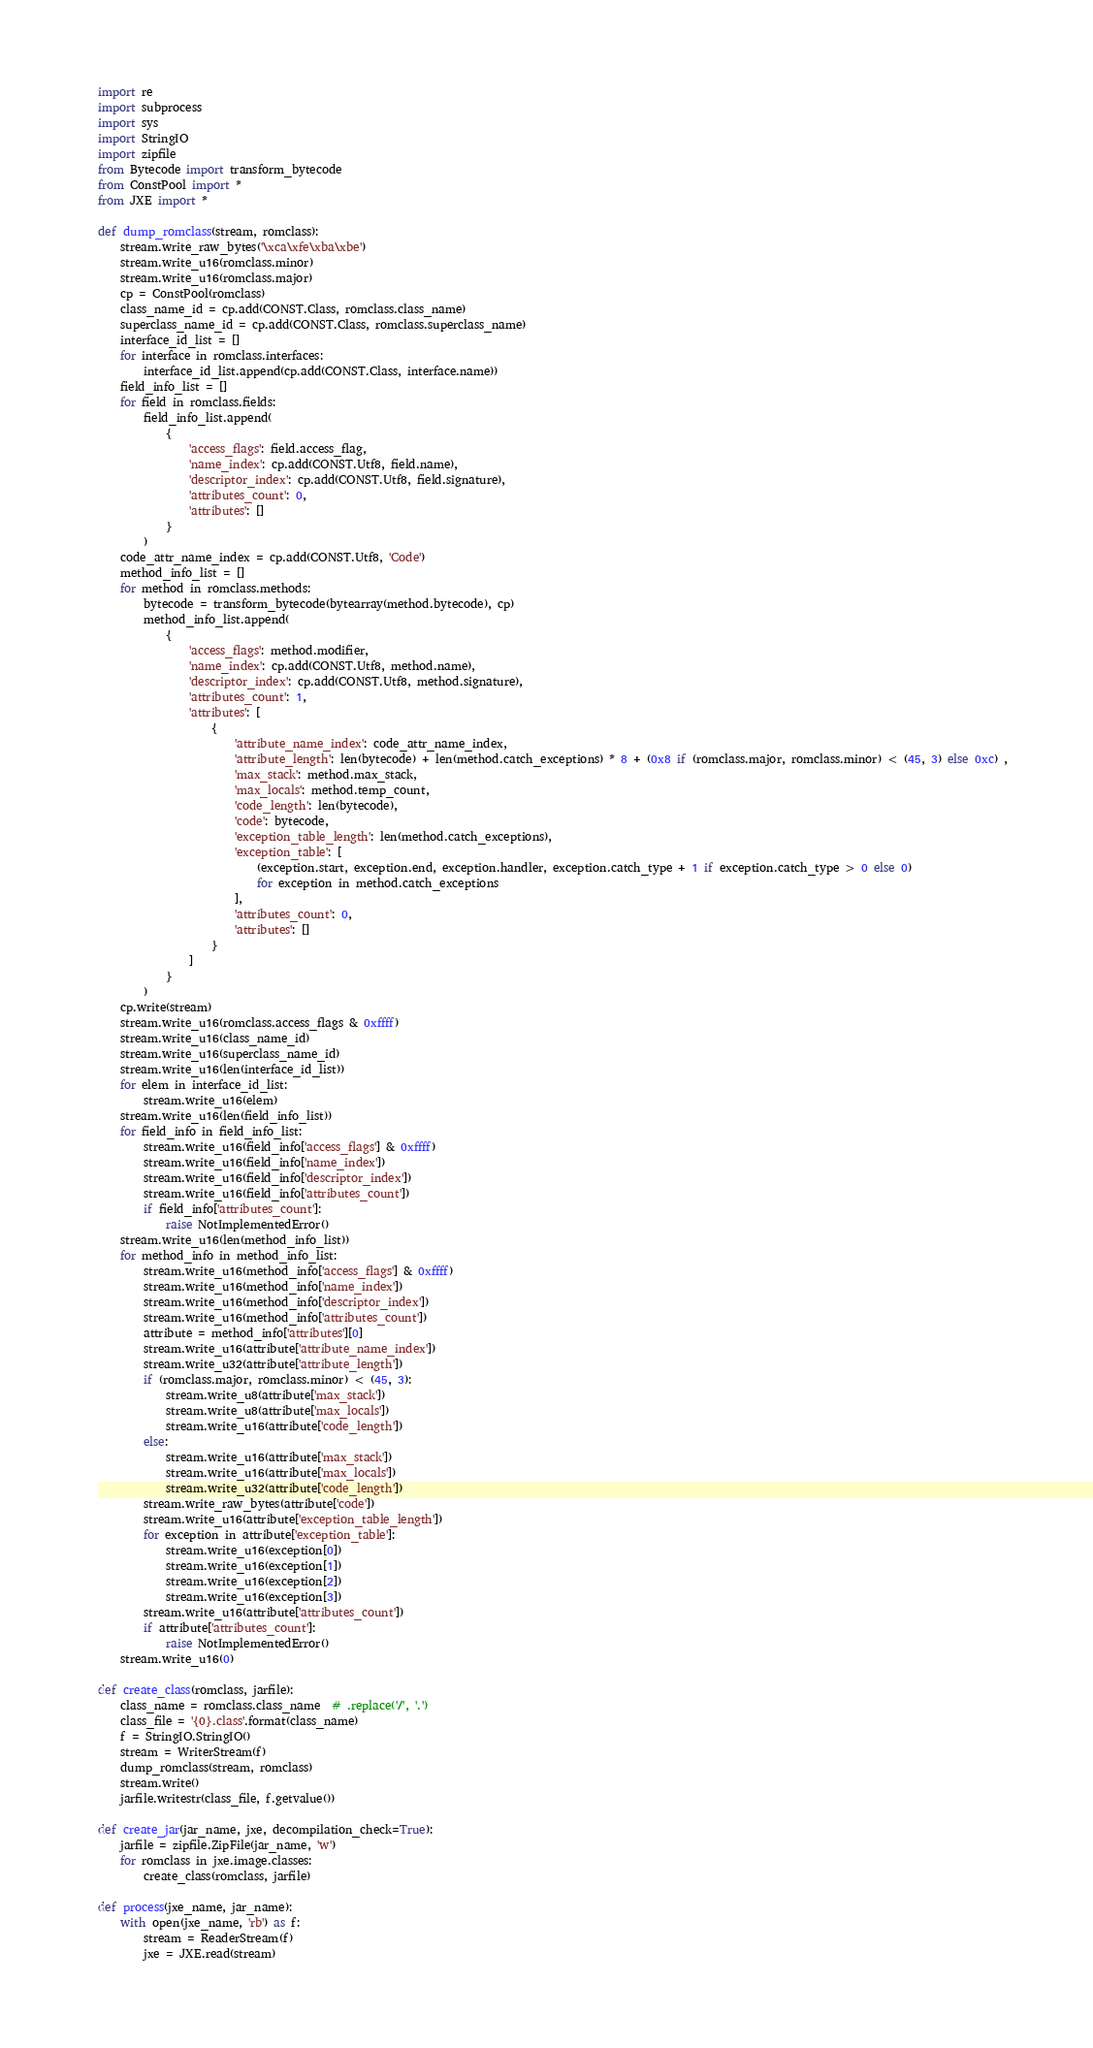<code> <loc_0><loc_0><loc_500><loc_500><_Python_>import re
import subprocess
import sys
import StringIO
import zipfile
from Bytecode import transform_bytecode
from ConstPool import *
from JXE import *

def dump_romclass(stream, romclass):
    stream.write_raw_bytes('\xca\xfe\xba\xbe')
    stream.write_u16(romclass.minor)
    stream.write_u16(romclass.major)
    cp = ConstPool(romclass)
    class_name_id = cp.add(CONST.Class, romclass.class_name)
    superclass_name_id = cp.add(CONST.Class, romclass.superclass_name)
    interface_id_list = []
    for interface in romclass.interfaces:
        interface_id_list.append(cp.add(CONST.Class, interface.name))
    field_info_list = []
    for field in romclass.fields:
        field_info_list.append(
            {
                'access_flags': field.access_flag,
                'name_index': cp.add(CONST.Utf8, field.name),
                'descriptor_index': cp.add(CONST.Utf8, field.signature),
                'attributes_count': 0,
                'attributes': []
            }
        )
    code_attr_name_index = cp.add(CONST.Utf8, 'Code')
    method_info_list = []
    for method in romclass.methods:
        bytecode = transform_bytecode(bytearray(method.bytecode), cp)
        method_info_list.append(
            {
                'access_flags': method.modifier,
                'name_index': cp.add(CONST.Utf8, method.name),
                'descriptor_index': cp.add(CONST.Utf8, method.signature),
                'attributes_count': 1,
                'attributes': [
                    {
                        'attribute_name_index': code_attr_name_index,
                        'attribute_length': len(bytecode) + len(method.catch_exceptions) * 8 + (0x8 if (romclass.major, romclass.minor) < (45, 3) else 0xc) ,
                        'max_stack': method.max_stack,
                        'max_locals': method.temp_count,
                        'code_length': len(bytecode),
                        'code': bytecode,
                        'exception_table_length': len(method.catch_exceptions),
                        'exception_table': [
                            (exception.start, exception.end, exception.handler, exception.catch_type + 1 if exception.catch_type > 0 else 0)
                            for exception in method.catch_exceptions
                        ],
                        'attributes_count': 0,
                        'attributes': []
                    }
                ]
            }
        )
    cp.write(stream)
    stream.write_u16(romclass.access_flags & 0xffff)
    stream.write_u16(class_name_id)
    stream.write_u16(superclass_name_id)
    stream.write_u16(len(interface_id_list))
    for elem in interface_id_list:
        stream.write_u16(elem)
    stream.write_u16(len(field_info_list))
    for field_info in field_info_list:
        stream.write_u16(field_info['access_flags'] & 0xffff)
        stream.write_u16(field_info['name_index'])
        stream.write_u16(field_info['descriptor_index'])
        stream.write_u16(field_info['attributes_count'])
        if field_info['attributes_count']:
            raise NotImplementedError()
    stream.write_u16(len(method_info_list))
    for method_info in method_info_list:
        stream.write_u16(method_info['access_flags'] & 0xffff)
        stream.write_u16(method_info['name_index'])
        stream.write_u16(method_info['descriptor_index'])
        stream.write_u16(method_info['attributes_count'])
        attribute = method_info['attributes'][0]
        stream.write_u16(attribute['attribute_name_index'])
        stream.write_u32(attribute['attribute_length'])
        if (romclass.major, romclass.minor) < (45, 3):
            stream.write_u8(attribute['max_stack'])
            stream.write_u8(attribute['max_locals'])
            stream.write_u16(attribute['code_length'])
        else:
            stream.write_u16(attribute['max_stack'])
            stream.write_u16(attribute['max_locals'])
            stream.write_u32(attribute['code_length'])
        stream.write_raw_bytes(attribute['code'])
        stream.write_u16(attribute['exception_table_length'])
        for exception in attribute['exception_table']:
            stream.write_u16(exception[0])
            stream.write_u16(exception[1])
            stream.write_u16(exception[2])
            stream.write_u16(exception[3])
        stream.write_u16(attribute['attributes_count'])
        if attribute['attributes_count']:
            raise NotImplementedError()
    stream.write_u16(0)

def create_class(romclass, jarfile):
    class_name = romclass.class_name  # .replace('/', '.')
    class_file = '{0}.class'.format(class_name)
    f = StringIO.StringIO()
    stream = WriterStream(f)
    dump_romclass(stream, romclass)
    stream.write()
    jarfile.writestr(class_file, f.getvalue())

def create_jar(jar_name, jxe, decompilation_check=True):
    jarfile = zipfile.ZipFile(jar_name, 'w')
    for romclass in jxe.image.classes:
        create_class(romclass, jarfile)

def process(jxe_name, jar_name):
    with open(jxe_name, 'rb') as f:
        stream = ReaderStream(f)
        jxe = JXE.read(stream)</code> 